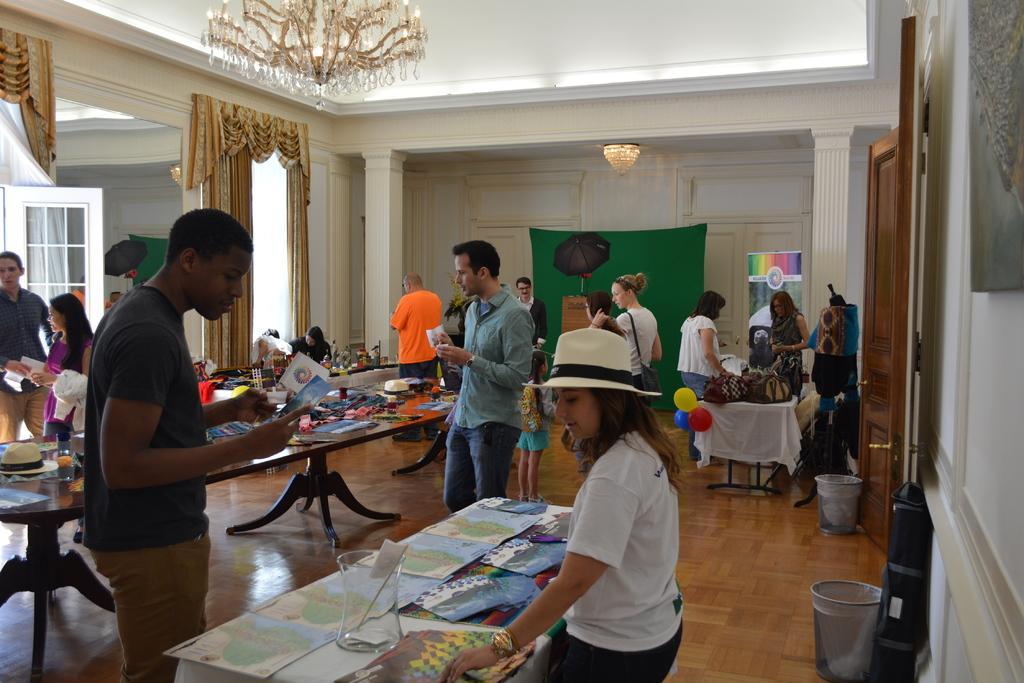Describe this image in one or two sentences. In this picture we can see a group of people where they are standing and holding papers in their hands and in front of them we can see table and on table we have cards, jar, some items, cap and in background we can see curtains, pillar, wall, light, chandelier. 